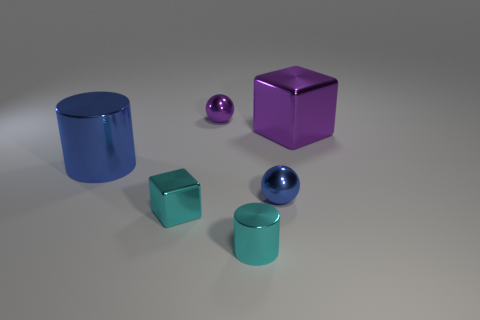Is the shape of the tiny purple thing the same as the small blue metallic object?
Give a very brief answer. Yes. What number of large objects are gray objects or purple shiny objects?
Keep it short and to the point. 1. What color is the large cylinder?
Your answer should be compact. Blue. What is the shape of the small cyan metallic thing that is to the right of the sphere that is behind the big purple thing?
Your answer should be very brief. Cylinder. Are there any purple blocks that have the same material as the large blue thing?
Provide a succinct answer. Yes. Is the size of the shiny sphere that is behind the purple metallic block the same as the cyan cube?
Your response must be concise. Yes. How many purple things are cylinders or small cubes?
Offer a terse response. 0. What is the tiny sphere left of the tiny shiny cylinder made of?
Provide a short and direct response. Metal. How many shiny things are on the right side of the purple thing to the left of the big shiny block?
Provide a succinct answer. 3. What number of blue rubber objects are the same shape as the big purple metal object?
Your answer should be compact. 0. 